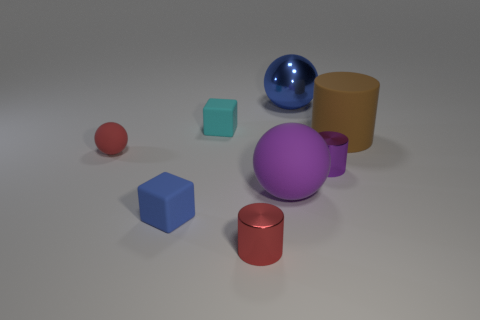Do the red ball and the brown cylinder have the same size?
Offer a terse response. No. The rubber cylinder has what color?
Ensure brevity in your answer.  Brown. How many objects are purple metal things or shiny spheres?
Keep it short and to the point. 2. Are there any small red metallic objects that have the same shape as the large shiny object?
Keep it short and to the point. No. Do the big ball that is in front of the red rubber thing and the large shiny ball have the same color?
Provide a short and direct response. No. The small thing that is on the right side of the red thing on the right side of the tiny blue block is what shape?
Make the answer very short. Cylinder. Are there any blue rubber balls that have the same size as the red sphere?
Your response must be concise. No. Is the number of big spheres less than the number of small red metallic cylinders?
Your answer should be very brief. No. There is a tiny red thing that is behind the purple cylinder that is behind the blue object that is to the left of the cyan cube; what is its shape?
Provide a short and direct response. Sphere. How many objects are either tiny cylinders right of the purple ball or shiny things behind the big cylinder?
Keep it short and to the point. 2. 